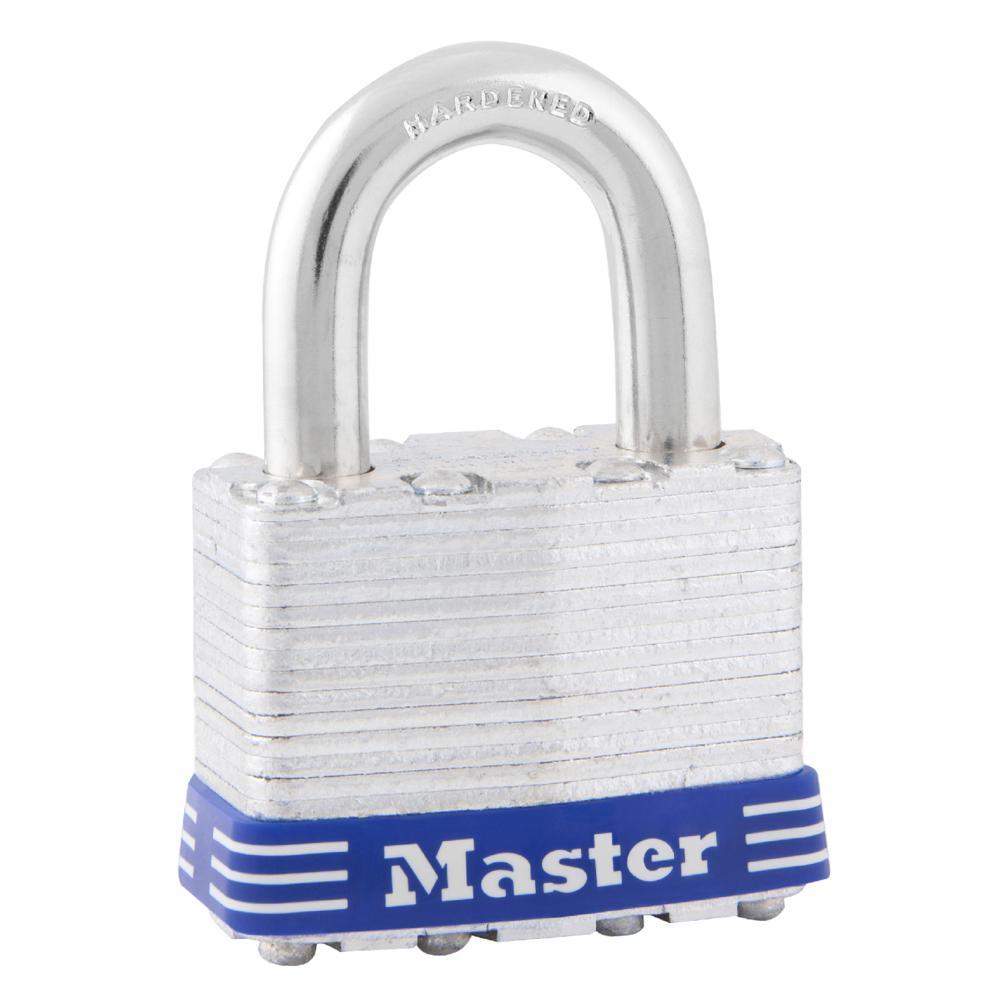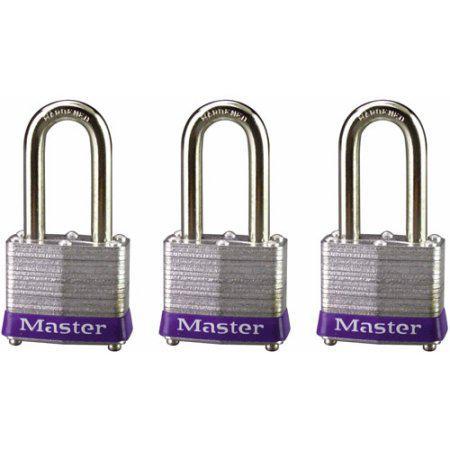The first image is the image on the left, the second image is the image on the right. Evaluate the accuracy of this statement regarding the images: "Two locks each have two keys and the same logo designs, but have differences in the lock mechanisms above the bases.". Is it true? Answer yes or no. No. The first image is the image on the left, the second image is the image on the right. For the images displayed, is the sentence "Each image contains only one lock, and each lock has a silver loop at the top." factually correct? Answer yes or no. No. 